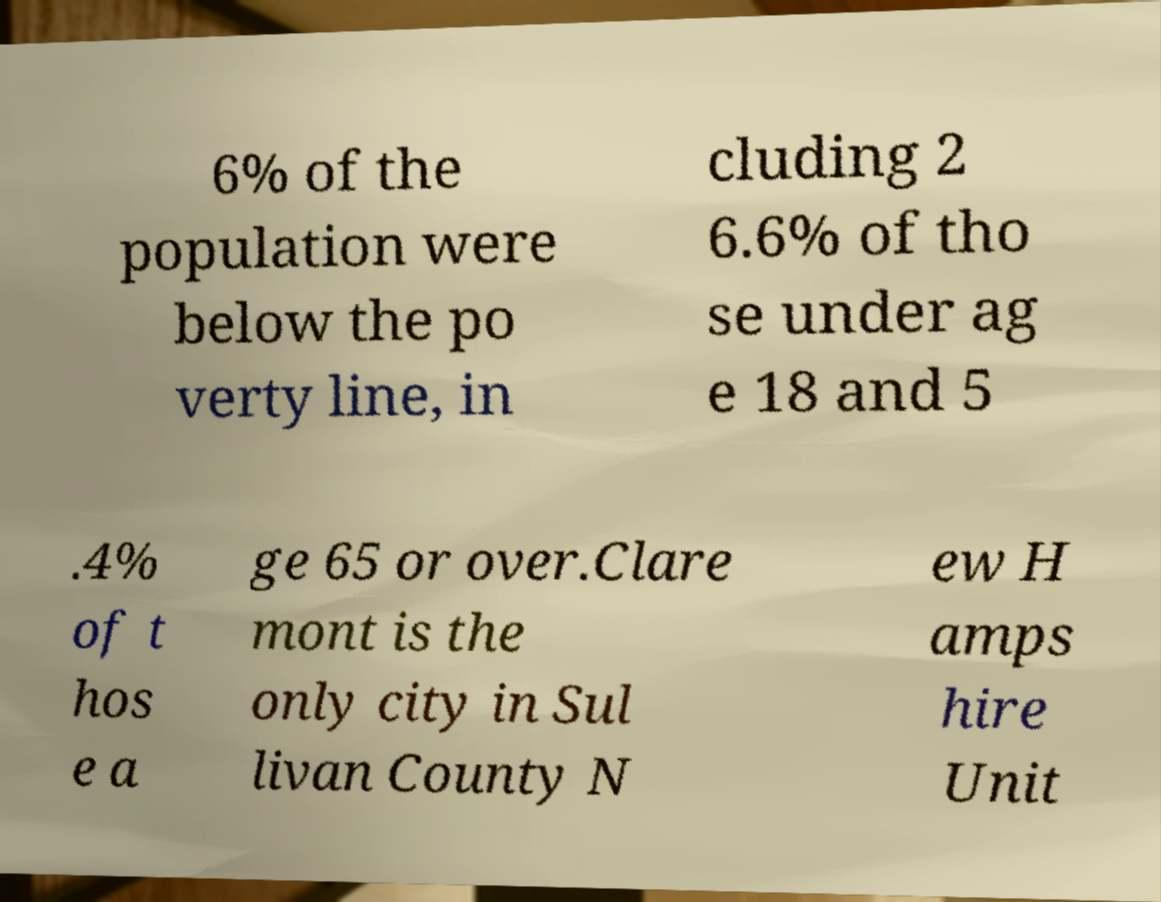What messages or text are displayed in this image? I need them in a readable, typed format. 6% of the population were below the po verty line, in cluding 2 6.6% of tho se under ag e 18 and 5 .4% of t hos e a ge 65 or over.Clare mont is the only city in Sul livan County N ew H amps hire Unit 